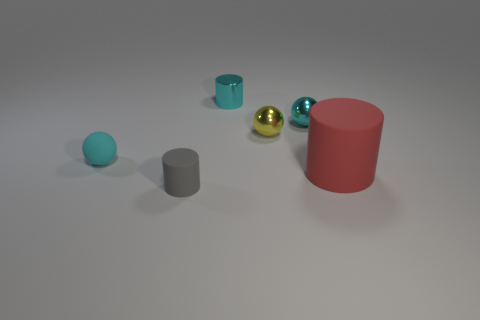Add 3 small yellow balls. How many objects exist? 9 Subtract 0 gray blocks. How many objects are left? 6 Subtract all small cyan metallic cylinders. Subtract all small gray cylinders. How many objects are left? 4 Add 2 cyan metal cylinders. How many cyan metal cylinders are left? 3 Add 4 tiny gray things. How many tiny gray things exist? 5 